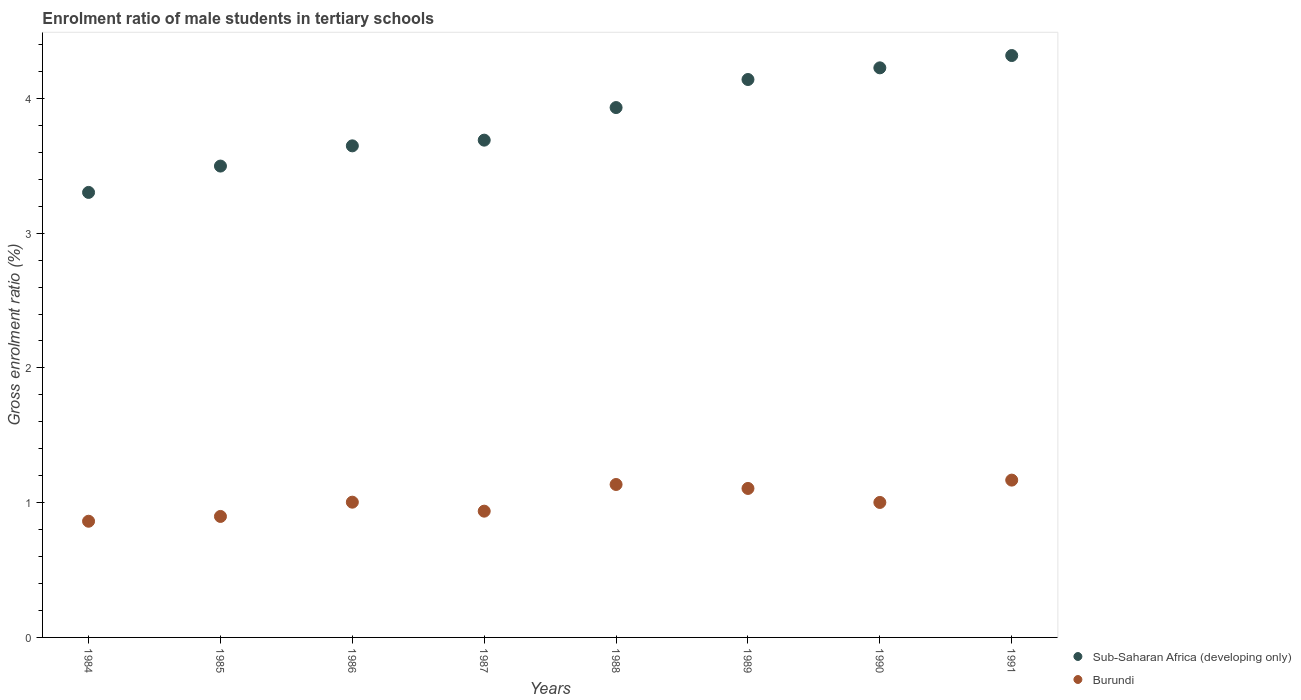Is the number of dotlines equal to the number of legend labels?
Offer a very short reply. Yes. What is the enrolment ratio of male students in tertiary schools in Burundi in 1990?
Offer a very short reply. 1. Across all years, what is the maximum enrolment ratio of male students in tertiary schools in Sub-Saharan Africa (developing only)?
Your response must be concise. 4.32. Across all years, what is the minimum enrolment ratio of male students in tertiary schools in Sub-Saharan Africa (developing only)?
Ensure brevity in your answer.  3.3. In which year was the enrolment ratio of male students in tertiary schools in Sub-Saharan Africa (developing only) minimum?
Your answer should be compact. 1984. What is the total enrolment ratio of male students in tertiary schools in Sub-Saharan Africa (developing only) in the graph?
Keep it short and to the point. 30.76. What is the difference between the enrolment ratio of male students in tertiary schools in Burundi in 1987 and that in 1989?
Give a very brief answer. -0.17. What is the difference between the enrolment ratio of male students in tertiary schools in Burundi in 1991 and the enrolment ratio of male students in tertiary schools in Sub-Saharan Africa (developing only) in 1986?
Offer a very short reply. -2.48. What is the average enrolment ratio of male students in tertiary schools in Sub-Saharan Africa (developing only) per year?
Ensure brevity in your answer.  3.84. In the year 1984, what is the difference between the enrolment ratio of male students in tertiary schools in Sub-Saharan Africa (developing only) and enrolment ratio of male students in tertiary schools in Burundi?
Keep it short and to the point. 2.44. What is the ratio of the enrolment ratio of male students in tertiary schools in Burundi in 1988 to that in 1991?
Ensure brevity in your answer.  0.97. Is the enrolment ratio of male students in tertiary schools in Burundi in 1984 less than that in 1989?
Ensure brevity in your answer.  Yes. Is the difference between the enrolment ratio of male students in tertiary schools in Sub-Saharan Africa (developing only) in 1985 and 1986 greater than the difference between the enrolment ratio of male students in tertiary schools in Burundi in 1985 and 1986?
Your answer should be compact. No. What is the difference between the highest and the second highest enrolment ratio of male students in tertiary schools in Burundi?
Your response must be concise. 0.03. What is the difference between the highest and the lowest enrolment ratio of male students in tertiary schools in Burundi?
Your answer should be very brief. 0.31. Does the enrolment ratio of male students in tertiary schools in Sub-Saharan Africa (developing only) monotonically increase over the years?
Your response must be concise. Yes. Is the enrolment ratio of male students in tertiary schools in Burundi strictly less than the enrolment ratio of male students in tertiary schools in Sub-Saharan Africa (developing only) over the years?
Keep it short and to the point. Yes. How many years are there in the graph?
Your response must be concise. 8. Are the values on the major ticks of Y-axis written in scientific E-notation?
Offer a very short reply. No. Where does the legend appear in the graph?
Your answer should be compact. Bottom right. How are the legend labels stacked?
Ensure brevity in your answer.  Vertical. What is the title of the graph?
Make the answer very short. Enrolment ratio of male students in tertiary schools. Does "Barbados" appear as one of the legend labels in the graph?
Ensure brevity in your answer.  No. What is the label or title of the X-axis?
Give a very brief answer. Years. What is the Gross enrolment ratio (%) of Sub-Saharan Africa (developing only) in 1984?
Your answer should be compact. 3.3. What is the Gross enrolment ratio (%) of Burundi in 1984?
Offer a terse response. 0.86. What is the Gross enrolment ratio (%) of Sub-Saharan Africa (developing only) in 1985?
Give a very brief answer. 3.5. What is the Gross enrolment ratio (%) in Burundi in 1985?
Offer a very short reply. 0.9. What is the Gross enrolment ratio (%) in Sub-Saharan Africa (developing only) in 1986?
Provide a short and direct response. 3.65. What is the Gross enrolment ratio (%) of Burundi in 1986?
Make the answer very short. 1. What is the Gross enrolment ratio (%) of Sub-Saharan Africa (developing only) in 1987?
Make the answer very short. 3.69. What is the Gross enrolment ratio (%) in Burundi in 1987?
Make the answer very short. 0.94. What is the Gross enrolment ratio (%) of Sub-Saharan Africa (developing only) in 1988?
Offer a terse response. 3.93. What is the Gross enrolment ratio (%) of Burundi in 1988?
Your answer should be compact. 1.14. What is the Gross enrolment ratio (%) of Sub-Saharan Africa (developing only) in 1989?
Provide a succinct answer. 4.14. What is the Gross enrolment ratio (%) of Burundi in 1989?
Your response must be concise. 1.11. What is the Gross enrolment ratio (%) of Sub-Saharan Africa (developing only) in 1990?
Ensure brevity in your answer.  4.23. What is the Gross enrolment ratio (%) in Burundi in 1990?
Offer a very short reply. 1. What is the Gross enrolment ratio (%) of Sub-Saharan Africa (developing only) in 1991?
Your answer should be compact. 4.32. What is the Gross enrolment ratio (%) in Burundi in 1991?
Provide a succinct answer. 1.17. Across all years, what is the maximum Gross enrolment ratio (%) in Sub-Saharan Africa (developing only)?
Your response must be concise. 4.32. Across all years, what is the maximum Gross enrolment ratio (%) in Burundi?
Make the answer very short. 1.17. Across all years, what is the minimum Gross enrolment ratio (%) in Sub-Saharan Africa (developing only)?
Offer a very short reply. 3.3. Across all years, what is the minimum Gross enrolment ratio (%) in Burundi?
Your answer should be compact. 0.86. What is the total Gross enrolment ratio (%) in Sub-Saharan Africa (developing only) in the graph?
Offer a very short reply. 30.76. What is the total Gross enrolment ratio (%) of Burundi in the graph?
Make the answer very short. 8.11. What is the difference between the Gross enrolment ratio (%) of Sub-Saharan Africa (developing only) in 1984 and that in 1985?
Give a very brief answer. -0.2. What is the difference between the Gross enrolment ratio (%) in Burundi in 1984 and that in 1985?
Offer a very short reply. -0.04. What is the difference between the Gross enrolment ratio (%) of Sub-Saharan Africa (developing only) in 1984 and that in 1986?
Ensure brevity in your answer.  -0.35. What is the difference between the Gross enrolment ratio (%) of Burundi in 1984 and that in 1986?
Your response must be concise. -0.14. What is the difference between the Gross enrolment ratio (%) of Sub-Saharan Africa (developing only) in 1984 and that in 1987?
Offer a very short reply. -0.39. What is the difference between the Gross enrolment ratio (%) in Burundi in 1984 and that in 1987?
Keep it short and to the point. -0.07. What is the difference between the Gross enrolment ratio (%) in Sub-Saharan Africa (developing only) in 1984 and that in 1988?
Offer a very short reply. -0.63. What is the difference between the Gross enrolment ratio (%) of Burundi in 1984 and that in 1988?
Provide a short and direct response. -0.27. What is the difference between the Gross enrolment ratio (%) of Sub-Saharan Africa (developing only) in 1984 and that in 1989?
Your answer should be very brief. -0.84. What is the difference between the Gross enrolment ratio (%) of Burundi in 1984 and that in 1989?
Your answer should be compact. -0.24. What is the difference between the Gross enrolment ratio (%) of Sub-Saharan Africa (developing only) in 1984 and that in 1990?
Make the answer very short. -0.92. What is the difference between the Gross enrolment ratio (%) of Burundi in 1984 and that in 1990?
Ensure brevity in your answer.  -0.14. What is the difference between the Gross enrolment ratio (%) of Sub-Saharan Africa (developing only) in 1984 and that in 1991?
Offer a very short reply. -1.02. What is the difference between the Gross enrolment ratio (%) of Burundi in 1984 and that in 1991?
Offer a terse response. -0.31. What is the difference between the Gross enrolment ratio (%) in Sub-Saharan Africa (developing only) in 1985 and that in 1986?
Provide a short and direct response. -0.15. What is the difference between the Gross enrolment ratio (%) of Burundi in 1985 and that in 1986?
Give a very brief answer. -0.11. What is the difference between the Gross enrolment ratio (%) in Sub-Saharan Africa (developing only) in 1985 and that in 1987?
Give a very brief answer. -0.19. What is the difference between the Gross enrolment ratio (%) in Burundi in 1985 and that in 1987?
Your answer should be compact. -0.04. What is the difference between the Gross enrolment ratio (%) of Sub-Saharan Africa (developing only) in 1985 and that in 1988?
Provide a short and direct response. -0.43. What is the difference between the Gross enrolment ratio (%) in Burundi in 1985 and that in 1988?
Ensure brevity in your answer.  -0.24. What is the difference between the Gross enrolment ratio (%) in Sub-Saharan Africa (developing only) in 1985 and that in 1989?
Your answer should be very brief. -0.64. What is the difference between the Gross enrolment ratio (%) of Burundi in 1985 and that in 1989?
Ensure brevity in your answer.  -0.21. What is the difference between the Gross enrolment ratio (%) in Sub-Saharan Africa (developing only) in 1985 and that in 1990?
Offer a terse response. -0.73. What is the difference between the Gross enrolment ratio (%) of Burundi in 1985 and that in 1990?
Your answer should be very brief. -0.1. What is the difference between the Gross enrolment ratio (%) of Sub-Saharan Africa (developing only) in 1985 and that in 1991?
Make the answer very short. -0.82. What is the difference between the Gross enrolment ratio (%) in Burundi in 1985 and that in 1991?
Ensure brevity in your answer.  -0.27. What is the difference between the Gross enrolment ratio (%) of Sub-Saharan Africa (developing only) in 1986 and that in 1987?
Ensure brevity in your answer.  -0.04. What is the difference between the Gross enrolment ratio (%) of Burundi in 1986 and that in 1987?
Offer a terse response. 0.07. What is the difference between the Gross enrolment ratio (%) in Sub-Saharan Africa (developing only) in 1986 and that in 1988?
Ensure brevity in your answer.  -0.28. What is the difference between the Gross enrolment ratio (%) in Burundi in 1986 and that in 1988?
Your answer should be compact. -0.13. What is the difference between the Gross enrolment ratio (%) in Sub-Saharan Africa (developing only) in 1986 and that in 1989?
Keep it short and to the point. -0.49. What is the difference between the Gross enrolment ratio (%) of Burundi in 1986 and that in 1989?
Provide a succinct answer. -0.1. What is the difference between the Gross enrolment ratio (%) in Sub-Saharan Africa (developing only) in 1986 and that in 1990?
Keep it short and to the point. -0.58. What is the difference between the Gross enrolment ratio (%) in Burundi in 1986 and that in 1990?
Your answer should be very brief. 0. What is the difference between the Gross enrolment ratio (%) in Sub-Saharan Africa (developing only) in 1986 and that in 1991?
Your response must be concise. -0.67. What is the difference between the Gross enrolment ratio (%) of Burundi in 1986 and that in 1991?
Your answer should be compact. -0.16. What is the difference between the Gross enrolment ratio (%) in Sub-Saharan Africa (developing only) in 1987 and that in 1988?
Provide a succinct answer. -0.24. What is the difference between the Gross enrolment ratio (%) in Burundi in 1987 and that in 1988?
Make the answer very short. -0.2. What is the difference between the Gross enrolment ratio (%) of Sub-Saharan Africa (developing only) in 1987 and that in 1989?
Give a very brief answer. -0.45. What is the difference between the Gross enrolment ratio (%) of Burundi in 1987 and that in 1989?
Offer a very short reply. -0.17. What is the difference between the Gross enrolment ratio (%) of Sub-Saharan Africa (developing only) in 1987 and that in 1990?
Ensure brevity in your answer.  -0.54. What is the difference between the Gross enrolment ratio (%) of Burundi in 1987 and that in 1990?
Your answer should be very brief. -0.06. What is the difference between the Gross enrolment ratio (%) of Sub-Saharan Africa (developing only) in 1987 and that in 1991?
Your answer should be compact. -0.63. What is the difference between the Gross enrolment ratio (%) of Burundi in 1987 and that in 1991?
Provide a short and direct response. -0.23. What is the difference between the Gross enrolment ratio (%) in Sub-Saharan Africa (developing only) in 1988 and that in 1989?
Your answer should be compact. -0.21. What is the difference between the Gross enrolment ratio (%) in Burundi in 1988 and that in 1989?
Give a very brief answer. 0.03. What is the difference between the Gross enrolment ratio (%) in Sub-Saharan Africa (developing only) in 1988 and that in 1990?
Your response must be concise. -0.29. What is the difference between the Gross enrolment ratio (%) in Burundi in 1988 and that in 1990?
Make the answer very short. 0.13. What is the difference between the Gross enrolment ratio (%) in Sub-Saharan Africa (developing only) in 1988 and that in 1991?
Provide a succinct answer. -0.39. What is the difference between the Gross enrolment ratio (%) of Burundi in 1988 and that in 1991?
Provide a succinct answer. -0.03. What is the difference between the Gross enrolment ratio (%) in Sub-Saharan Africa (developing only) in 1989 and that in 1990?
Give a very brief answer. -0.09. What is the difference between the Gross enrolment ratio (%) in Burundi in 1989 and that in 1990?
Provide a succinct answer. 0.1. What is the difference between the Gross enrolment ratio (%) in Sub-Saharan Africa (developing only) in 1989 and that in 1991?
Provide a short and direct response. -0.18. What is the difference between the Gross enrolment ratio (%) in Burundi in 1989 and that in 1991?
Make the answer very short. -0.06. What is the difference between the Gross enrolment ratio (%) in Sub-Saharan Africa (developing only) in 1990 and that in 1991?
Your answer should be very brief. -0.09. What is the difference between the Gross enrolment ratio (%) of Burundi in 1990 and that in 1991?
Offer a terse response. -0.17. What is the difference between the Gross enrolment ratio (%) in Sub-Saharan Africa (developing only) in 1984 and the Gross enrolment ratio (%) in Burundi in 1985?
Keep it short and to the point. 2.4. What is the difference between the Gross enrolment ratio (%) in Sub-Saharan Africa (developing only) in 1984 and the Gross enrolment ratio (%) in Burundi in 1986?
Your answer should be compact. 2.3. What is the difference between the Gross enrolment ratio (%) in Sub-Saharan Africa (developing only) in 1984 and the Gross enrolment ratio (%) in Burundi in 1987?
Your answer should be very brief. 2.37. What is the difference between the Gross enrolment ratio (%) of Sub-Saharan Africa (developing only) in 1984 and the Gross enrolment ratio (%) of Burundi in 1988?
Provide a short and direct response. 2.17. What is the difference between the Gross enrolment ratio (%) of Sub-Saharan Africa (developing only) in 1984 and the Gross enrolment ratio (%) of Burundi in 1989?
Ensure brevity in your answer.  2.2. What is the difference between the Gross enrolment ratio (%) of Sub-Saharan Africa (developing only) in 1984 and the Gross enrolment ratio (%) of Burundi in 1990?
Your answer should be very brief. 2.3. What is the difference between the Gross enrolment ratio (%) in Sub-Saharan Africa (developing only) in 1984 and the Gross enrolment ratio (%) in Burundi in 1991?
Provide a succinct answer. 2.14. What is the difference between the Gross enrolment ratio (%) in Sub-Saharan Africa (developing only) in 1985 and the Gross enrolment ratio (%) in Burundi in 1986?
Provide a short and direct response. 2.49. What is the difference between the Gross enrolment ratio (%) in Sub-Saharan Africa (developing only) in 1985 and the Gross enrolment ratio (%) in Burundi in 1987?
Your response must be concise. 2.56. What is the difference between the Gross enrolment ratio (%) in Sub-Saharan Africa (developing only) in 1985 and the Gross enrolment ratio (%) in Burundi in 1988?
Provide a succinct answer. 2.36. What is the difference between the Gross enrolment ratio (%) in Sub-Saharan Africa (developing only) in 1985 and the Gross enrolment ratio (%) in Burundi in 1989?
Your answer should be very brief. 2.39. What is the difference between the Gross enrolment ratio (%) of Sub-Saharan Africa (developing only) in 1985 and the Gross enrolment ratio (%) of Burundi in 1990?
Make the answer very short. 2.5. What is the difference between the Gross enrolment ratio (%) in Sub-Saharan Africa (developing only) in 1985 and the Gross enrolment ratio (%) in Burundi in 1991?
Keep it short and to the point. 2.33. What is the difference between the Gross enrolment ratio (%) of Sub-Saharan Africa (developing only) in 1986 and the Gross enrolment ratio (%) of Burundi in 1987?
Offer a very short reply. 2.71. What is the difference between the Gross enrolment ratio (%) of Sub-Saharan Africa (developing only) in 1986 and the Gross enrolment ratio (%) of Burundi in 1988?
Provide a short and direct response. 2.51. What is the difference between the Gross enrolment ratio (%) of Sub-Saharan Africa (developing only) in 1986 and the Gross enrolment ratio (%) of Burundi in 1989?
Provide a short and direct response. 2.54. What is the difference between the Gross enrolment ratio (%) of Sub-Saharan Africa (developing only) in 1986 and the Gross enrolment ratio (%) of Burundi in 1990?
Offer a terse response. 2.65. What is the difference between the Gross enrolment ratio (%) in Sub-Saharan Africa (developing only) in 1986 and the Gross enrolment ratio (%) in Burundi in 1991?
Make the answer very short. 2.48. What is the difference between the Gross enrolment ratio (%) in Sub-Saharan Africa (developing only) in 1987 and the Gross enrolment ratio (%) in Burundi in 1988?
Your answer should be very brief. 2.56. What is the difference between the Gross enrolment ratio (%) in Sub-Saharan Africa (developing only) in 1987 and the Gross enrolment ratio (%) in Burundi in 1989?
Offer a terse response. 2.58. What is the difference between the Gross enrolment ratio (%) in Sub-Saharan Africa (developing only) in 1987 and the Gross enrolment ratio (%) in Burundi in 1990?
Keep it short and to the point. 2.69. What is the difference between the Gross enrolment ratio (%) of Sub-Saharan Africa (developing only) in 1987 and the Gross enrolment ratio (%) of Burundi in 1991?
Your response must be concise. 2.52. What is the difference between the Gross enrolment ratio (%) in Sub-Saharan Africa (developing only) in 1988 and the Gross enrolment ratio (%) in Burundi in 1989?
Give a very brief answer. 2.83. What is the difference between the Gross enrolment ratio (%) in Sub-Saharan Africa (developing only) in 1988 and the Gross enrolment ratio (%) in Burundi in 1990?
Your answer should be very brief. 2.93. What is the difference between the Gross enrolment ratio (%) in Sub-Saharan Africa (developing only) in 1988 and the Gross enrolment ratio (%) in Burundi in 1991?
Provide a succinct answer. 2.76. What is the difference between the Gross enrolment ratio (%) of Sub-Saharan Africa (developing only) in 1989 and the Gross enrolment ratio (%) of Burundi in 1990?
Provide a succinct answer. 3.14. What is the difference between the Gross enrolment ratio (%) in Sub-Saharan Africa (developing only) in 1989 and the Gross enrolment ratio (%) in Burundi in 1991?
Provide a short and direct response. 2.97. What is the difference between the Gross enrolment ratio (%) of Sub-Saharan Africa (developing only) in 1990 and the Gross enrolment ratio (%) of Burundi in 1991?
Make the answer very short. 3.06. What is the average Gross enrolment ratio (%) of Sub-Saharan Africa (developing only) per year?
Provide a succinct answer. 3.84. What is the average Gross enrolment ratio (%) in Burundi per year?
Ensure brevity in your answer.  1.01. In the year 1984, what is the difference between the Gross enrolment ratio (%) in Sub-Saharan Africa (developing only) and Gross enrolment ratio (%) in Burundi?
Your answer should be very brief. 2.44. In the year 1985, what is the difference between the Gross enrolment ratio (%) in Sub-Saharan Africa (developing only) and Gross enrolment ratio (%) in Burundi?
Provide a succinct answer. 2.6. In the year 1986, what is the difference between the Gross enrolment ratio (%) of Sub-Saharan Africa (developing only) and Gross enrolment ratio (%) of Burundi?
Keep it short and to the point. 2.64. In the year 1987, what is the difference between the Gross enrolment ratio (%) in Sub-Saharan Africa (developing only) and Gross enrolment ratio (%) in Burundi?
Give a very brief answer. 2.75. In the year 1988, what is the difference between the Gross enrolment ratio (%) of Sub-Saharan Africa (developing only) and Gross enrolment ratio (%) of Burundi?
Your answer should be very brief. 2.8. In the year 1989, what is the difference between the Gross enrolment ratio (%) in Sub-Saharan Africa (developing only) and Gross enrolment ratio (%) in Burundi?
Provide a short and direct response. 3.03. In the year 1990, what is the difference between the Gross enrolment ratio (%) in Sub-Saharan Africa (developing only) and Gross enrolment ratio (%) in Burundi?
Your answer should be compact. 3.23. In the year 1991, what is the difference between the Gross enrolment ratio (%) in Sub-Saharan Africa (developing only) and Gross enrolment ratio (%) in Burundi?
Give a very brief answer. 3.15. What is the ratio of the Gross enrolment ratio (%) in Sub-Saharan Africa (developing only) in 1984 to that in 1985?
Provide a succinct answer. 0.94. What is the ratio of the Gross enrolment ratio (%) in Burundi in 1984 to that in 1985?
Keep it short and to the point. 0.96. What is the ratio of the Gross enrolment ratio (%) in Sub-Saharan Africa (developing only) in 1984 to that in 1986?
Offer a very short reply. 0.91. What is the ratio of the Gross enrolment ratio (%) of Burundi in 1984 to that in 1986?
Provide a succinct answer. 0.86. What is the ratio of the Gross enrolment ratio (%) of Sub-Saharan Africa (developing only) in 1984 to that in 1987?
Your answer should be very brief. 0.89. What is the ratio of the Gross enrolment ratio (%) in Burundi in 1984 to that in 1987?
Your answer should be very brief. 0.92. What is the ratio of the Gross enrolment ratio (%) in Sub-Saharan Africa (developing only) in 1984 to that in 1988?
Your response must be concise. 0.84. What is the ratio of the Gross enrolment ratio (%) of Burundi in 1984 to that in 1988?
Your answer should be compact. 0.76. What is the ratio of the Gross enrolment ratio (%) of Sub-Saharan Africa (developing only) in 1984 to that in 1989?
Keep it short and to the point. 0.8. What is the ratio of the Gross enrolment ratio (%) of Burundi in 1984 to that in 1989?
Provide a succinct answer. 0.78. What is the ratio of the Gross enrolment ratio (%) in Sub-Saharan Africa (developing only) in 1984 to that in 1990?
Offer a terse response. 0.78. What is the ratio of the Gross enrolment ratio (%) in Burundi in 1984 to that in 1990?
Your answer should be compact. 0.86. What is the ratio of the Gross enrolment ratio (%) of Sub-Saharan Africa (developing only) in 1984 to that in 1991?
Your response must be concise. 0.76. What is the ratio of the Gross enrolment ratio (%) of Burundi in 1984 to that in 1991?
Your answer should be compact. 0.74. What is the ratio of the Gross enrolment ratio (%) of Sub-Saharan Africa (developing only) in 1985 to that in 1986?
Make the answer very short. 0.96. What is the ratio of the Gross enrolment ratio (%) in Burundi in 1985 to that in 1986?
Your response must be concise. 0.89. What is the ratio of the Gross enrolment ratio (%) of Sub-Saharan Africa (developing only) in 1985 to that in 1987?
Provide a succinct answer. 0.95. What is the ratio of the Gross enrolment ratio (%) of Burundi in 1985 to that in 1987?
Your response must be concise. 0.96. What is the ratio of the Gross enrolment ratio (%) of Sub-Saharan Africa (developing only) in 1985 to that in 1988?
Provide a succinct answer. 0.89. What is the ratio of the Gross enrolment ratio (%) of Burundi in 1985 to that in 1988?
Give a very brief answer. 0.79. What is the ratio of the Gross enrolment ratio (%) of Sub-Saharan Africa (developing only) in 1985 to that in 1989?
Your response must be concise. 0.84. What is the ratio of the Gross enrolment ratio (%) in Burundi in 1985 to that in 1989?
Provide a short and direct response. 0.81. What is the ratio of the Gross enrolment ratio (%) in Sub-Saharan Africa (developing only) in 1985 to that in 1990?
Your answer should be very brief. 0.83. What is the ratio of the Gross enrolment ratio (%) in Burundi in 1985 to that in 1990?
Provide a short and direct response. 0.9. What is the ratio of the Gross enrolment ratio (%) in Sub-Saharan Africa (developing only) in 1985 to that in 1991?
Provide a short and direct response. 0.81. What is the ratio of the Gross enrolment ratio (%) of Burundi in 1985 to that in 1991?
Ensure brevity in your answer.  0.77. What is the ratio of the Gross enrolment ratio (%) in Sub-Saharan Africa (developing only) in 1986 to that in 1987?
Provide a short and direct response. 0.99. What is the ratio of the Gross enrolment ratio (%) in Burundi in 1986 to that in 1987?
Offer a terse response. 1.07. What is the ratio of the Gross enrolment ratio (%) of Sub-Saharan Africa (developing only) in 1986 to that in 1988?
Your answer should be compact. 0.93. What is the ratio of the Gross enrolment ratio (%) in Burundi in 1986 to that in 1988?
Your answer should be compact. 0.88. What is the ratio of the Gross enrolment ratio (%) in Sub-Saharan Africa (developing only) in 1986 to that in 1989?
Your answer should be compact. 0.88. What is the ratio of the Gross enrolment ratio (%) of Burundi in 1986 to that in 1989?
Give a very brief answer. 0.91. What is the ratio of the Gross enrolment ratio (%) in Sub-Saharan Africa (developing only) in 1986 to that in 1990?
Provide a short and direct response. 0.86. What is the ratio of the Gross enrolment ratio (%) of Sub-Saharan Africa (developing only) in 1986 to that in 1991?
Keep it short and to the point. 0.84. What is the ratio of the Gross enrolment ratio (%) of Burundi in 1986 to that in 1991?
Give a very brief answer. 0.86. What is the ratio of the Gross enrolment ratio (%) in Sub-Saharan Africa (developing only) in 1987 to that in 1988?
Ensure brevity in your answer.  0.94. What is the ratio of the Gross enrolment ratio (%) of Burundi in 1987 to that in 1988?
Ensure brevity in your answer.  0.83. What is the ratio of the Gross enrolment ratio (%) of Sub-Saharan Africa (developing only) in 1987 to that in 1989?
Give a very brief answer. 0.89. What is the ratio of the Gross enrolment ratio (%) in Burundi in 1987 to that in 1989?
Keep it short and to the point. 0.85. What is the ratio of the Gross enrolment ratio (%) of Sub-Saharan Africa (developing only) in 1987 to that in 1990?
Your answer should be very brief. 0.87. What is the ratio of the Gross enrolment ratio (%) of Burundi in 1987 to that in 1990?
Your answer should be compact. 0.94. What is the ratio of the Gross enrolment ratio (%) in Sub-Saharan Africa (developing only) in 1987 to that in 1991?
Offer a very short reply. 0.85. What is the ratio of the Gross enrolment ratio (%) in Burundi in 1987 to that in 1991?
Your answer should be compact. 0.8. What is the ratio of the Gross enrolment ratio (%) in Sub-Saharan Africa (developing only) in 1988 to that in 1989?
Make the answer very short. 0.95. What is the ratio of the Gross enrolment ratio (%) in Burundi in 1988 to that in 1989?
Make the answer very short. 1.03. What is the ratio of the Gross enrolment ratio (%) in Sub-Saharan Africa (developing only) in 1988 to that in 1990?
Provide a short and direct response. 0.93. What is the ratio of the Gross enrolment ratio (%) in Burundi in 1988 to that in 1990?
Your answer should be very brief. 1.13. What is the ratio of the Gross enrolment ratio (%) in Sub-Saharan Africa (developing only) in 1988 to that in 1991?
Offer a very short reply. 0.91. What is the ratio of the Gross enrolment ratio (%) of Burundi in 1988 to that in 1991?
Provide a succinct answer. 0.97. What is the ratio of the Gross enrolment ratio (%) in Sub-Saharan Africa (developing only) in 1989 to that in 1990?
Provide a short and direct response. 0.98. What is the ratio of the Gross enrolment ratio (%) in Burundi in 1989 to that in 1990?
Give a very brief answer. 1.1. What is the ratio of the Gross enrolment ratio (%) of Sub-Saharan Africa (developing only) in 1989 to that in 1991?
Ensure brevity in your answer.  0.96. What is the ratio of the Gross enrolment ratio (%) of Burundi in 1989 to that in 1991?
Your answer should be very brief. 0.95. What is the ratio of the Gross enrolment ratio (%) of Sub-Saharan Africa (developing only) in 1990 to that in 1991?
Your answer should be very brief. 0.98. What is the ratio of the Gross enrolment ratio (%) of Burundi in 1990 to that in 1991?
Your response must be concise. 0.86. What is the difference between the highest and the second highest Gross enrolment ratio (%) in Sub-Saharan Africa (developing only)?
Provide a succinct answer. 0.09. What is the difference between the highest and the second highest Gross enrolment ratio (%) of Burundi?
Offer a terse response. 0.03. What is the difference between the highest and the lowest Gross enrolment ratio (%) in Sub-Saharan Africa (developing only)?
Offer a terse response. 1.02. What is the difference between the highest and the lowest Gross enrolment ratio (%) of Burundi?
Your answer should be very brief. 0.31. 